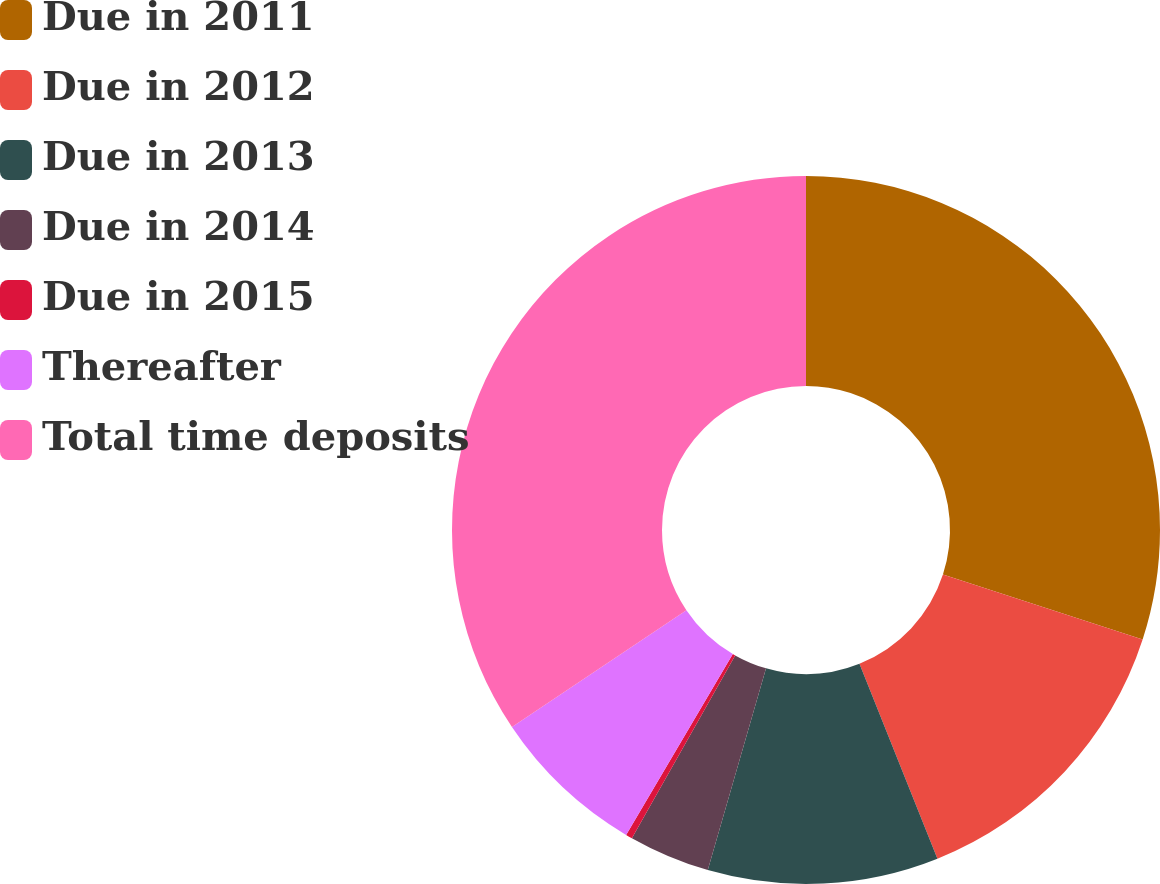Convert chart. <chart><loc_0><loc_0><loc_500><loc_500><pie_chart><fcel>Due in 2011<fcel>Due in 2012<fcel>Due in 2013<fcel>Due in 2014<fcel>Due in 2015<fcel>Thereafter<fcel>Total time deposits<nl><fcel>30.01%<fcel>13.94%<fcel>10.53%<fcel>3.71%<fcel>0.3%<fcel>7.12%<fcel>34.4%<nl></chart> 